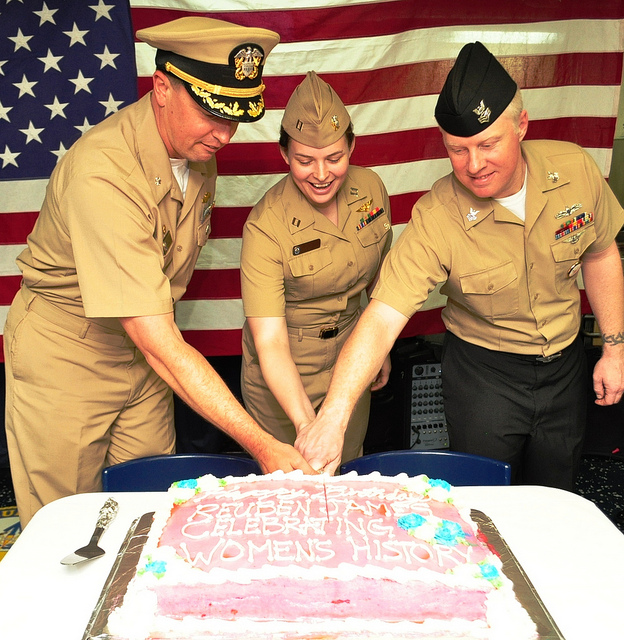Identify and read out the text in this image. HAPPY BIRTHDAY BEUBEN HISTORY WOMENS CELEBRATING JAMES 